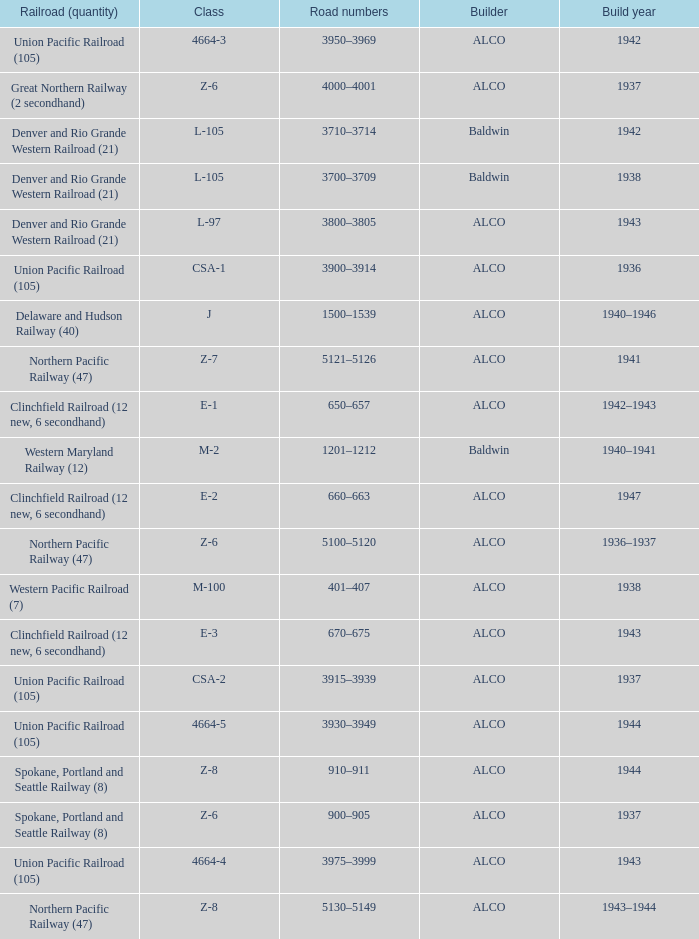What is the road numbers when the build year is 1943, the railroad (quantity) is clinchfield railroad (12 new, 6 secondhand)? 670–675. 